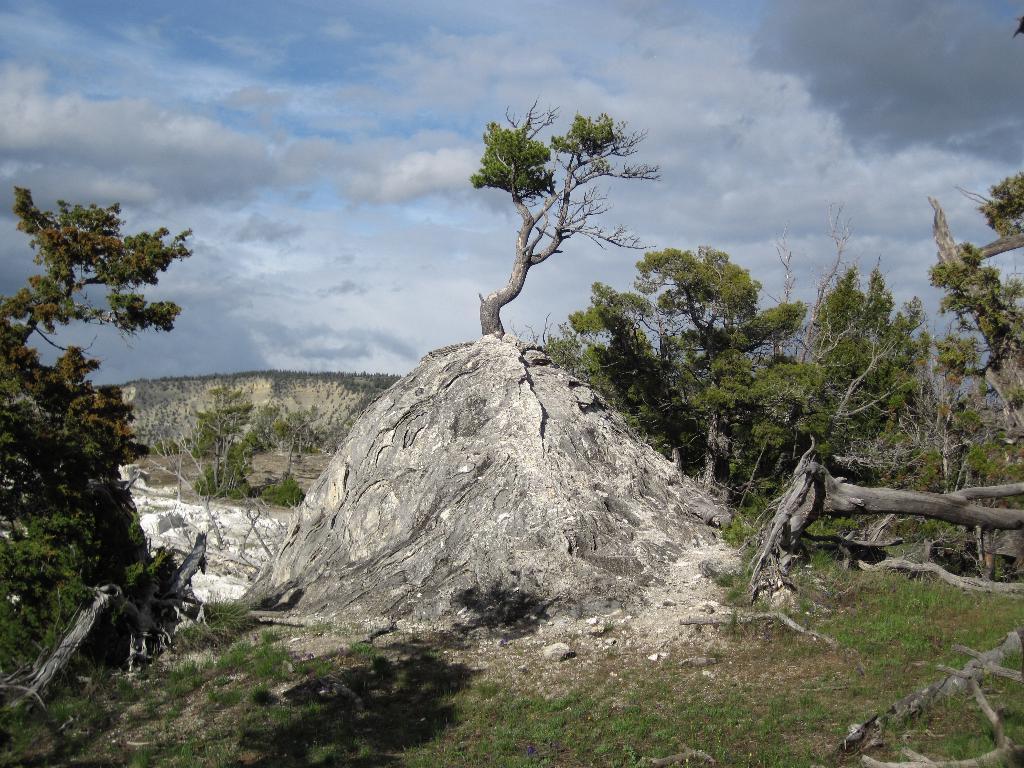Could you give a brief overview of what you see in this image? In the picture we can see a grass surface on it, we can see some plants and a rock hill with a tree on it and in the background also we can see some hills and sky with clouds. 